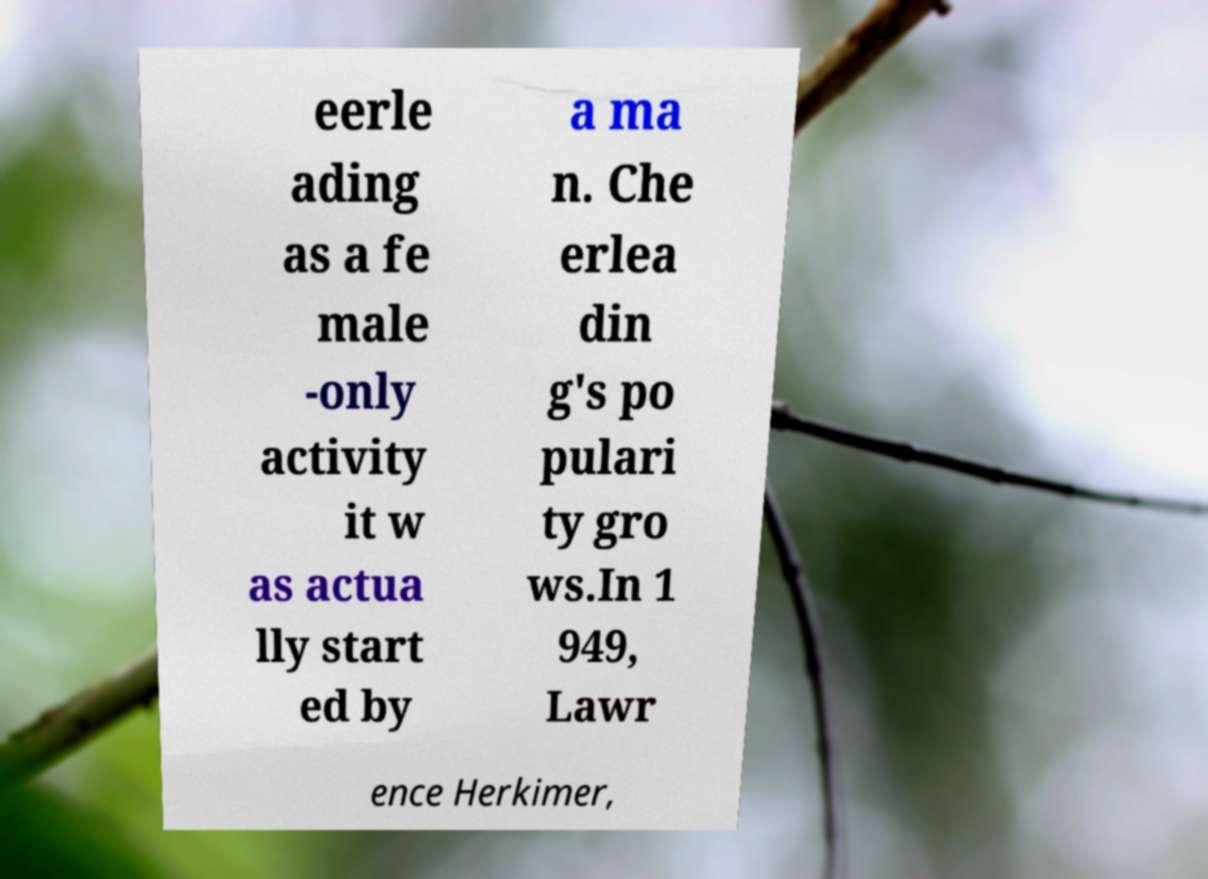I need the written content from this picture converted into text. Can you do that? eerle ading as a fe male -only activity it w as actua lly start ed by a ma n. Che erlea din g's po pulari ty gro ws.In 1 949, Lawr ence Herkimer, 